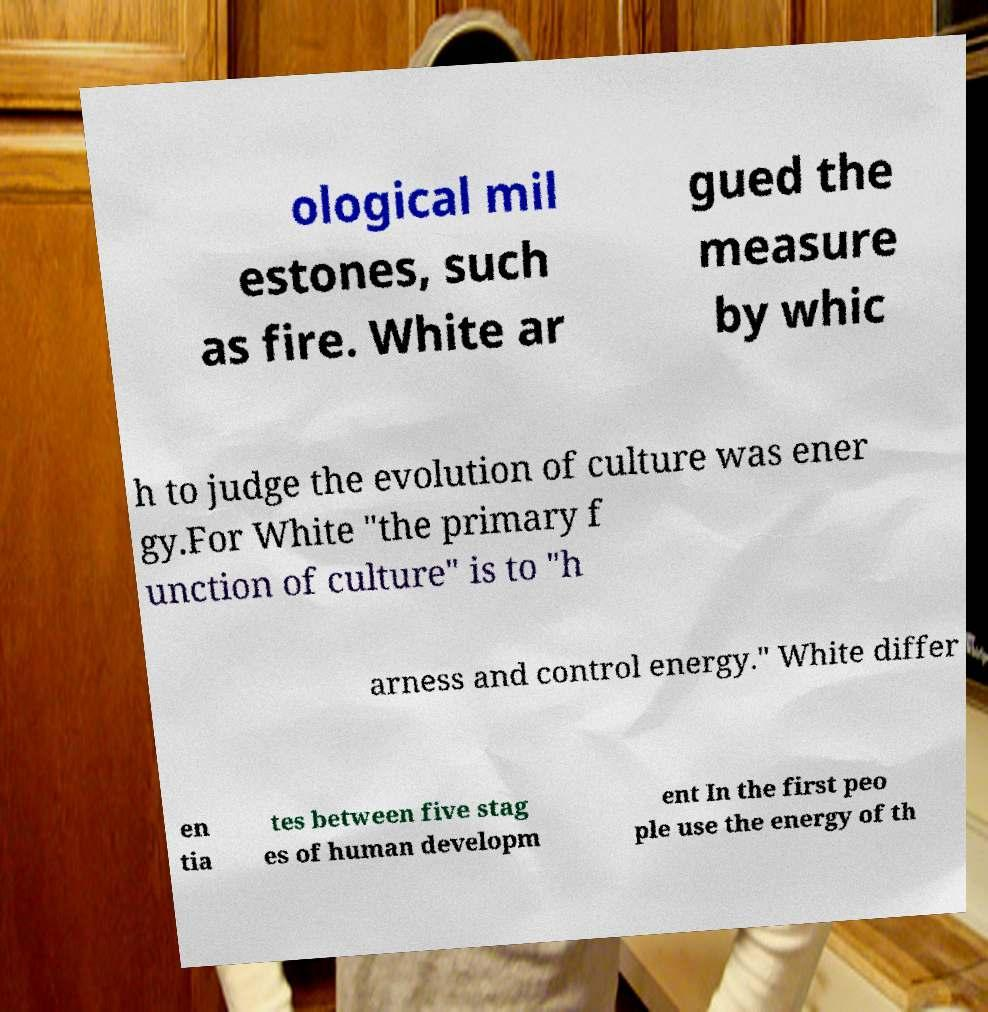There's text embedded in this image that I need extracted. Can you transcribe it verbatim? ological mil estones, such as fire. White ar gued the measure by whic h to judge the evolution of culture was ener gy.For White "the primary f unction of culture" is to "h arness and control energy." White differ en tia tes between five stag es of human developm ent In the first peo ple use the energy of th 